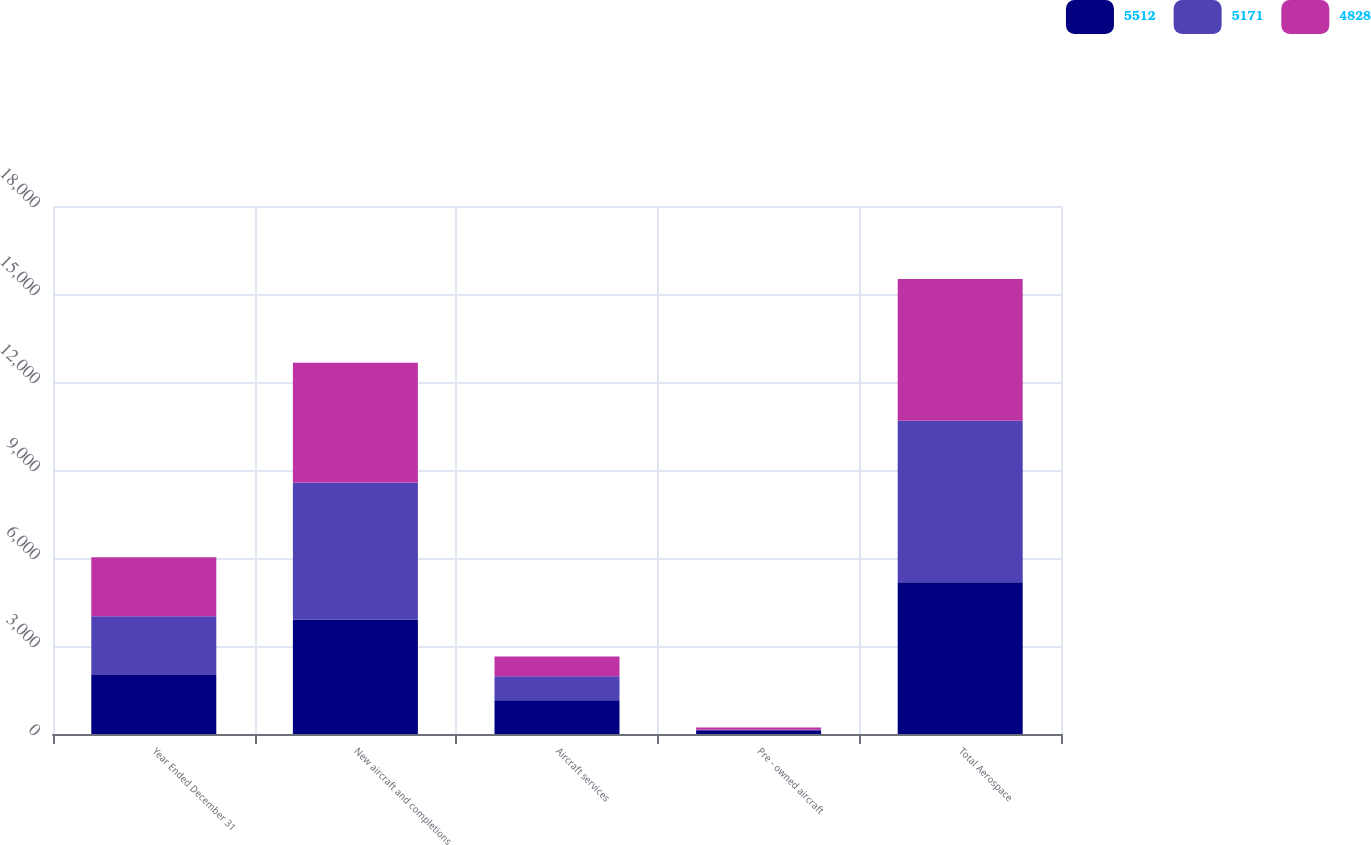<chart> <loc_0><loc_0><loc_500><loc_500><stacked_bar_chart><ecel><fcel>Year Ended December 31<fcel>New aircraft and completions<fcel>Aircraft services<fcel>Pre - owned aircraft<fcel>Total Aerospace<nl><fcel>5512<fcel>2009<fcel>3893<fcel>1154<fcel>124<fcel>5171<nl><fcel>5171<fcel>2008<fcel>4678<fcel>816<fcel>18<fcel>5512<nl><fcel>4828<fcel>2007<fcel>4081<fcel>669<fcel>78<fcel>4828<nl></chart> 